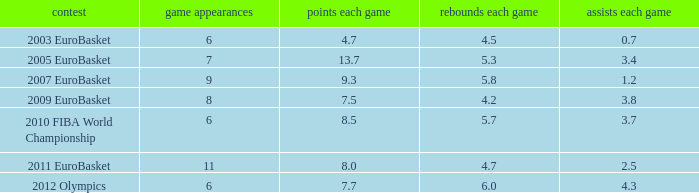How many games played have 4.7 points per game? 1.0. 